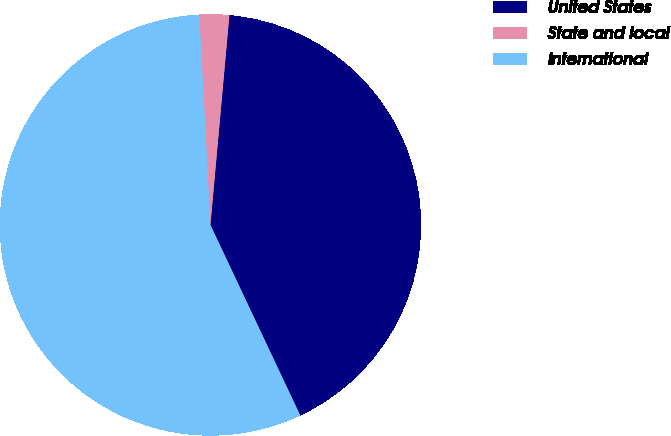<chart> <loc_0><loc_0><loc_500><loc_500><pie_chart><fcel>United States<fcel>State and local<fcel>International<nl><fcel>41.55%<fcel>2.28%<fcel>56.17%<nl></chart> 